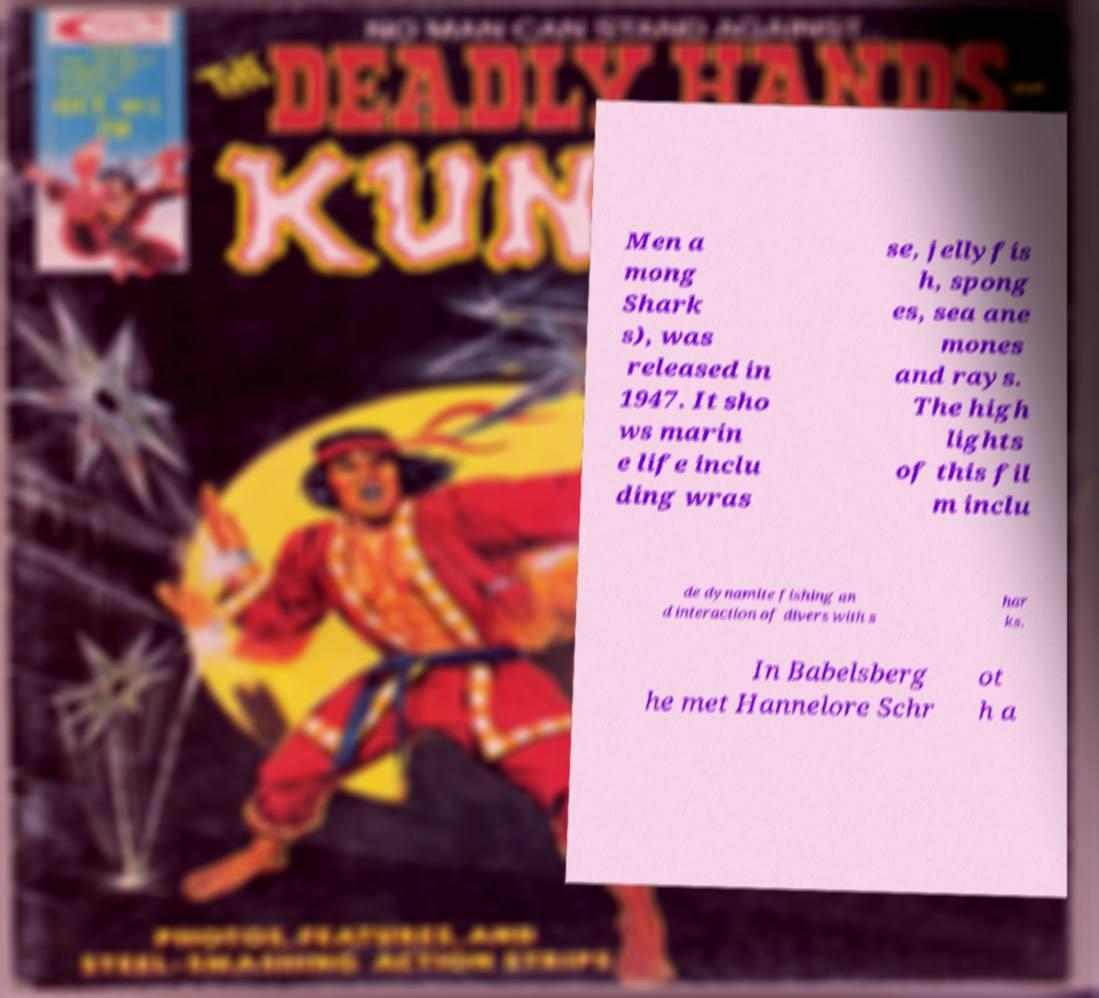I need the written content from this picture converted into text. Can you do that? Men a mong Shark s), was released in 1947. It sho ws marin e life inclu ding wras se, jellyfis h, spong es, sea ane mones and rays. The high lights of this fil m inclu de dynamite fishing an d interaction of divers with s har ks. In Babelsberg he met Hannelore Schr ot h a 